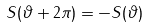Convert formula to latex. <formula><loc_0><loc_0><loc_500><loc_500>S ( \vartheta + 2 \pi ) = - S ( \vartheta )</formula> 